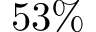Convert formula to latex. <formula><loc_0><loc_0><loc_500><loc_500>5 3 \%</formula> 